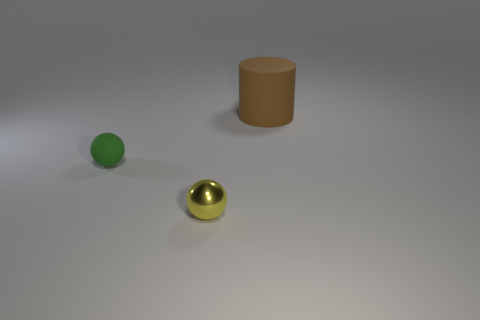Subtract all red cylinders. Subtract all cyan blocks. How many cylinders are left? 1 Add 3 gray metallic cubes. How many objects exist? 6 Subtract all cylinders. How many objects are left? 2 Add 3 small balls. How many small balls exist? 5 Subtract 0 red blocks. How many objects are left? 3 Subtract all green rubber spheres. Subtract all small blue cubes. How many objects are left? 2 Add 2 small green things. How many small green things are left? 3 